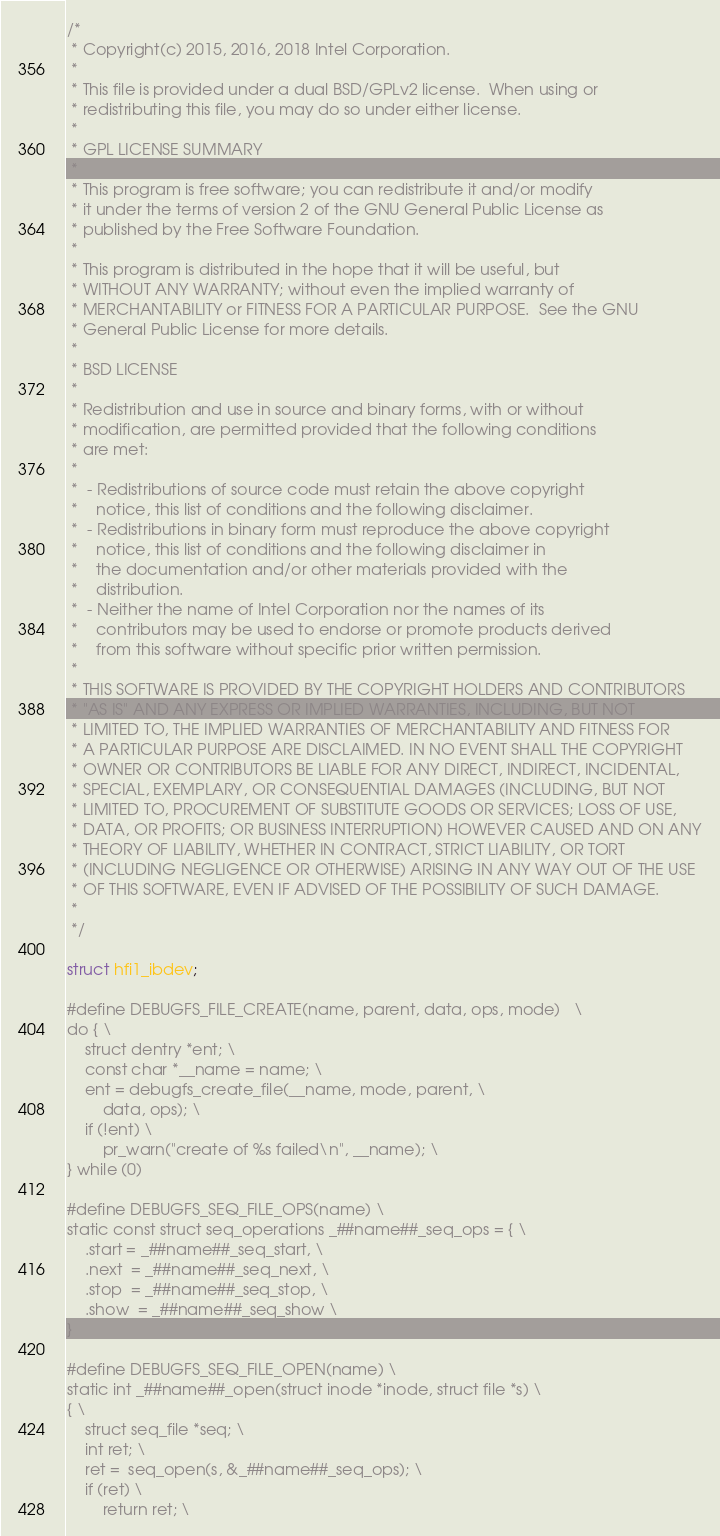<code> <loc_0><loc_0><loc_500><loc_500><_C_>/*
 * Copyright(c) 2015, 2016, 2018 Intel Corporation.
 *
 * This file is provided under a dual BSD/GPLv2 license.  When using or
 * redistributing this file, you may do so under either license.
 *
 * GPL LICENSE SUMMARY
 *
 * This program is free software; you can redistribute it and/or modify
 * it under the terms of version 2 of the GNU General Public License as
 * published by the Free Software Foundation.
 *
 * This program is distributed in the hope that it will be useful, but
 * WITHOUT ANY WARRANTY; without even the implied warranty of
 * MERCHANTABILITY or FITNESS FOR A PARTICULAR PURPOSE.  See the GNU
 * General Public License for more details.
 *
 * BSD LICENSE
 *
 * Redistribution and use in source and binary forms, with or without
 * modification, are permitted provided that the following conditions
 * are met:
 *
 *  - Redistributions of source code must retain the above copyright
 *    notice, this list of conditions and the following disclaimer.
 *  - Redistributions in binary form must reproduce the above copyright
 *    notice, this list of conditions and the following disclaimer in
 *    the documentation and/or other materials provided with the
 *    distribution.
 *  - Neither the name of Intel Corporation nor the names of its
 *    contributors may be used to endorse or promote products derived
 *    from this software without specific prior written permission.
 *
 * THIS SOFTWARE IS PROVIDED BY THE COPYRIGHT HOLDERS AND CONTRIBUTORS
 * "AS IS" AND ANY EXPRESS OR IMPLIED WARRANTIES, INCLUDING, BUT NOT
 * LIMITED TO, THE IMPLIED WARRANTIES OF MERCHANTABILITY AND FITNESS FOR
 * A PARTICULAR PURPOSE ARE DISCLAIMED. IN NO EVENT SHALL THE COPYRIGHT
 * OWNER OR CONTRIBUTORS BE LIABLE FOR ANY DIRECT, INDIRECT, INCIDENTAL,
 * SPECIAL, EXEMPLARY, OR CONSEQUENTIAL DAMAGES (INCLUDING, BUT NOT
 * LIMITED TO, PROCUREMENT OF SUBSTITUTE GOODS OR SERVICES; LOSS OF USE,
 * DATA, OR PROFITS; OR BUSINESS INTERRUPTION) HOWEVER CAUSED AND ON ANY
 * THEORY OF LIABILITY, WHETHER IN CONTRACT, STRICT LIABILITY, OR TORT
 * (INCLUDING NEGLIGENCE OR OTHERWISE) ARISING IN ANY WAY OUT OF THE USE
 * OF THIS SOFTWARE, EVEN IF ADVISED OF THE POSSIBILITY OF SUCH DAMAGE.
 *
 */

struct hfi1_ibdev;

#define DEBUGFS_FILE_CREATE(name, parent, data, ops, mode)	\
do { \
	struct dentry *ent; \
	const char *__name = name; \
	ent = debugfs_create_file(__name, mode, parent, \
		data, ops); \
	if (!ent) \
		pr_warn("create of %s failed\n", __name); \
} while (0)

#define DEBUGFS_SEQ_FILE_OPS(name) \
static const struct seq_operations _##name##_seq_ops = { \
	.start = _##name##_seq_start, \
	.next  = _##name##_seq_next, \
	.stop  = _##name##_seq_stop, \
	.show  = _##name##_seq_show \
}

#define DEBUGFS_SEQ_FILE_OPEN(name) \
static int _##name##_open(struct inode *inode, struct file *s) \
{ \
	struct seq_file *seq; \
	int ret; \
	ret =  seq_open(s, &_##name##_seq_ops); \
	if (ret) \
		return ret; \</code> 